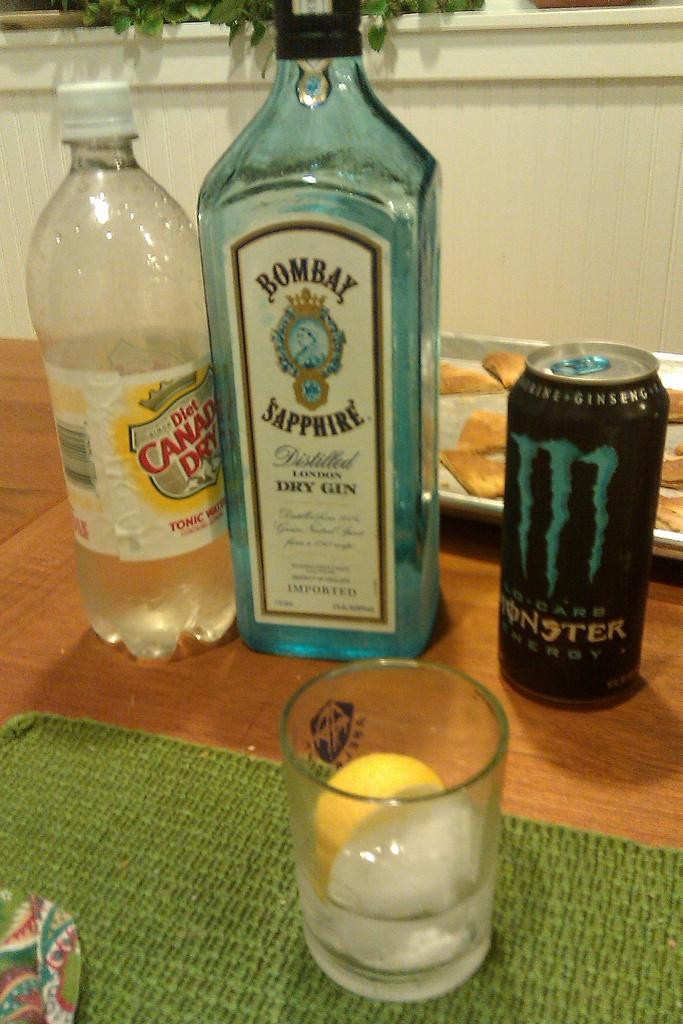<image>
Provide a brief description of the given image. Tonic, gin and monster drink are on the table behind a glass of mixed drink. 